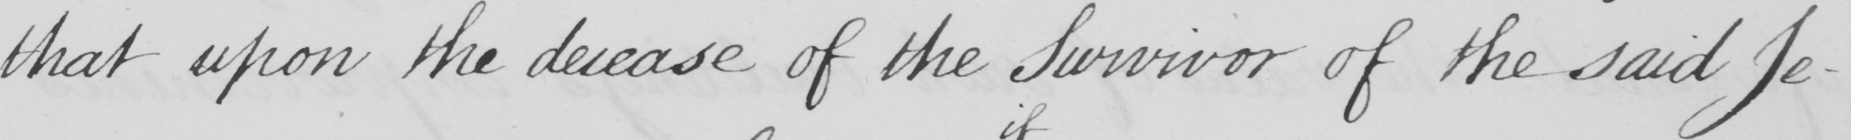What is written in this line of handwriting? that upon the decease of the Survivor of the said Je- 